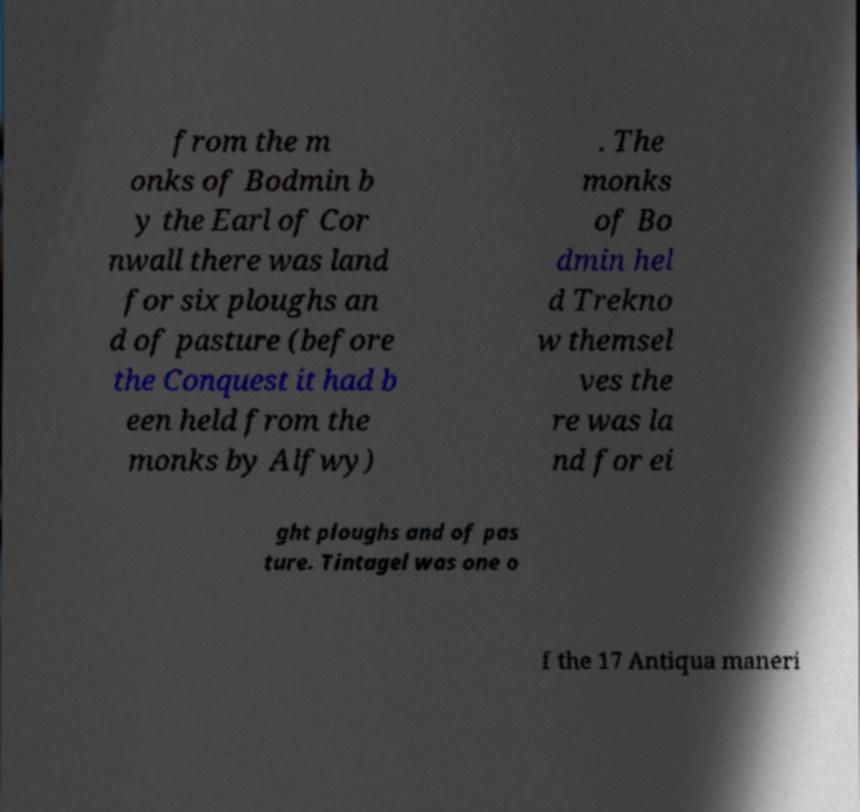I need the written content from this picture converted into text. Can you do that? from the m onks of Bodmin b y the Earl of Cor nwall there was land for six ploughs an d of pasture (before the Conquest it had b een held from the monks by Alfwy) . The monks of Bo dmin hel d Trekno w themsel ves the re was la nd for ei ght ploughs and of pas ture. Tintagel was one o f the 17 Antiqua maneri 